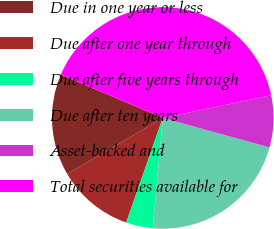Convert chart to OTSL. <chart><loc_0><loc_0><loc_500><loc_500><pie_chart><fcel>Due in one year or less<fcel>Due after one year through<fcel>Due after five years through<fcel>Due after ten years<fcel>Asset-backed and<fcel>Total securities available for<nl><fcel>14.84%<fcel>11.2%<fcel>3.92%<fcel>22.16%<fcel>7.56%<fcel>40.32%<nl></chart> 